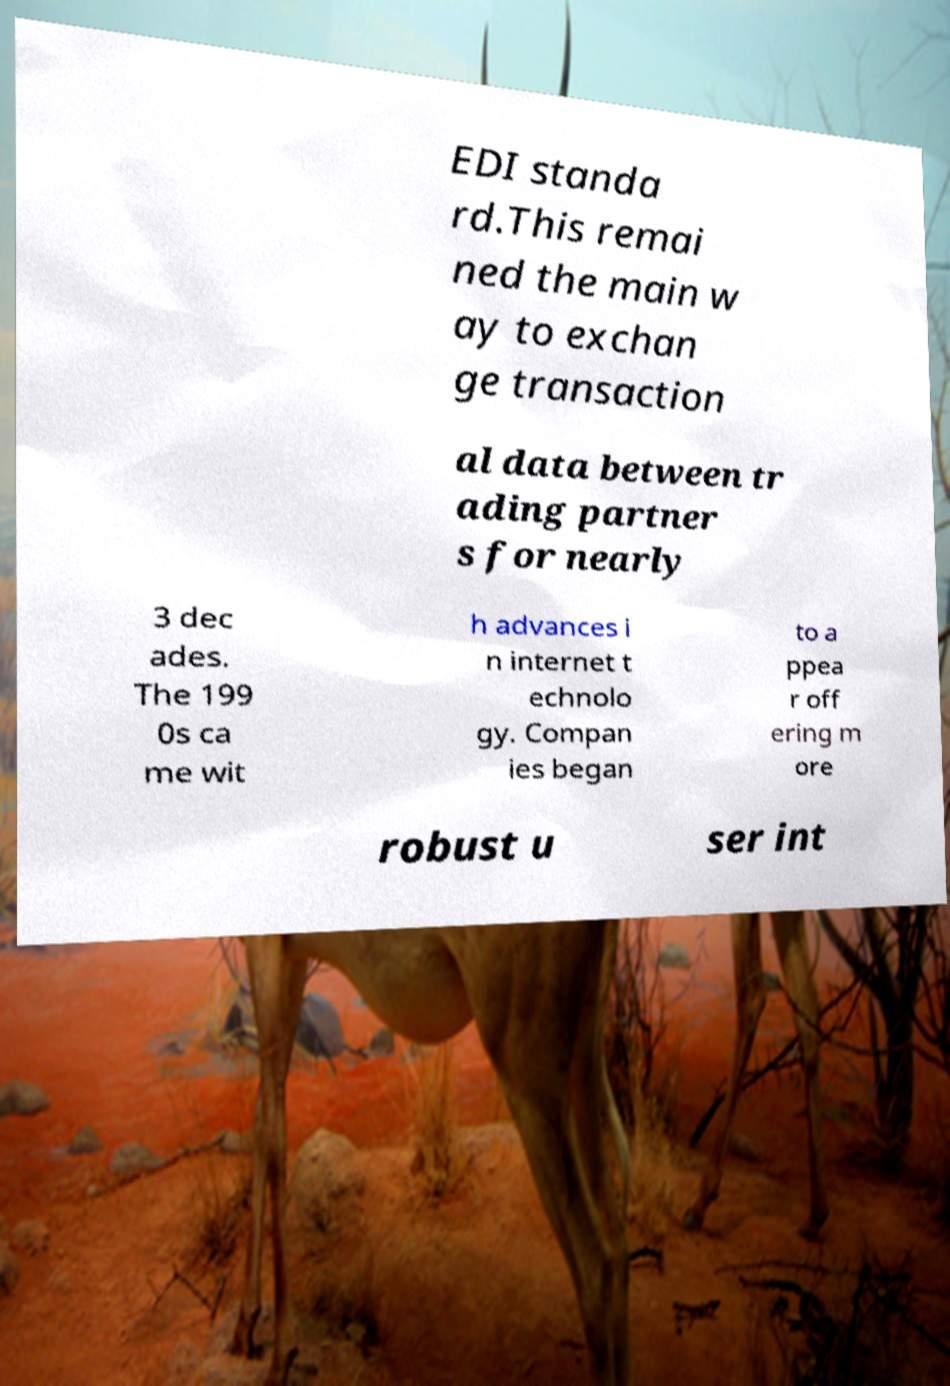There's text embedded in this image that I need extracted. Can you transcribe it verbatim? EDI standa rd.This remai ned the main w ay to exchan ge transaction al data between tr ading partner s for nearly 3 dec ades. The 199 0s ca me wit h advances i n internet t echnolo gy. Compan ies began to a ppea r off ering m ore robust u ser int 